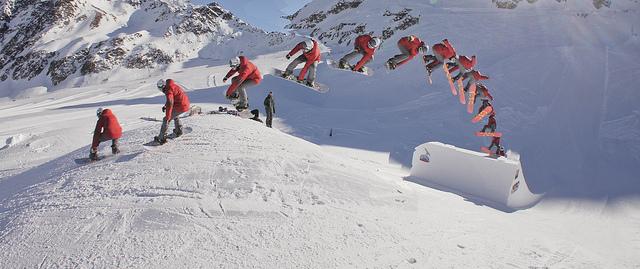What is red and white striped?
Give a very brief answer. Snowboard. What sport is shown?
Quick response, please. Snowboarding. What color are their coats?
Be succinct. Red. Is this all one person?
Be succinct. Yes. 